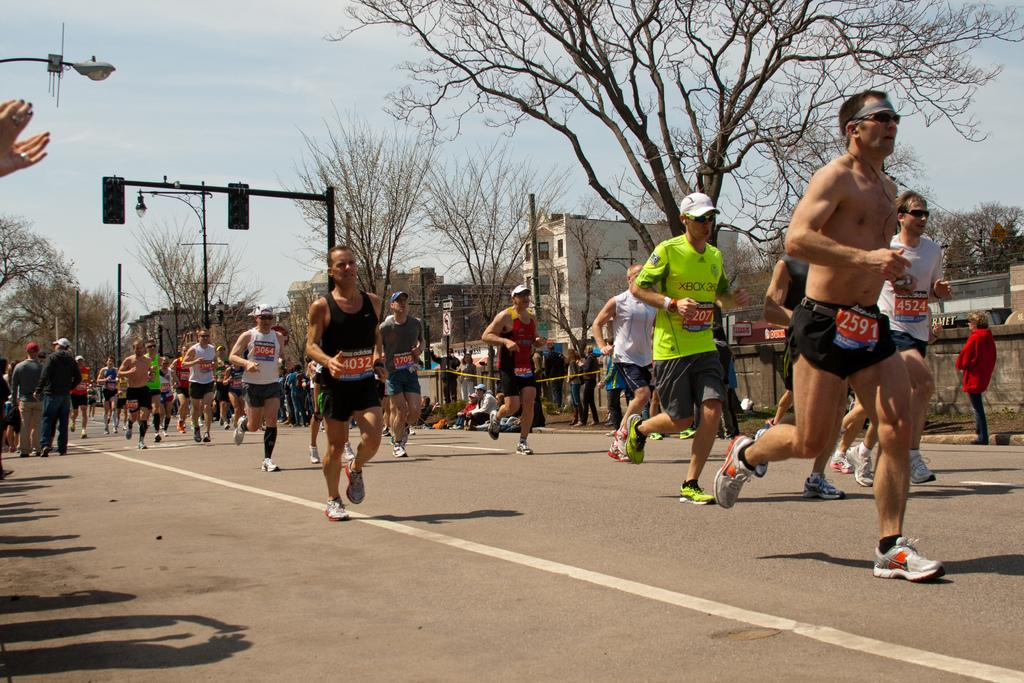What are the people in the image doing? The people in the image are running. What can be seen on the shirts the people are wearing? The people are wearing shirts with codes. What is visible in the background of the image? There are trees, poles, and buildings in the background of the image. What is the condition of the sky in the image? The sky is clear in the image. Can you tell me how many fathers are running with the tiger in the image? There is no father or tiger present in the image; it features people running with codes on their shirts. What fact can be learned about the tiger from the image? There is no tiger present in the image, so no fact about a tiger can be learned from it. 